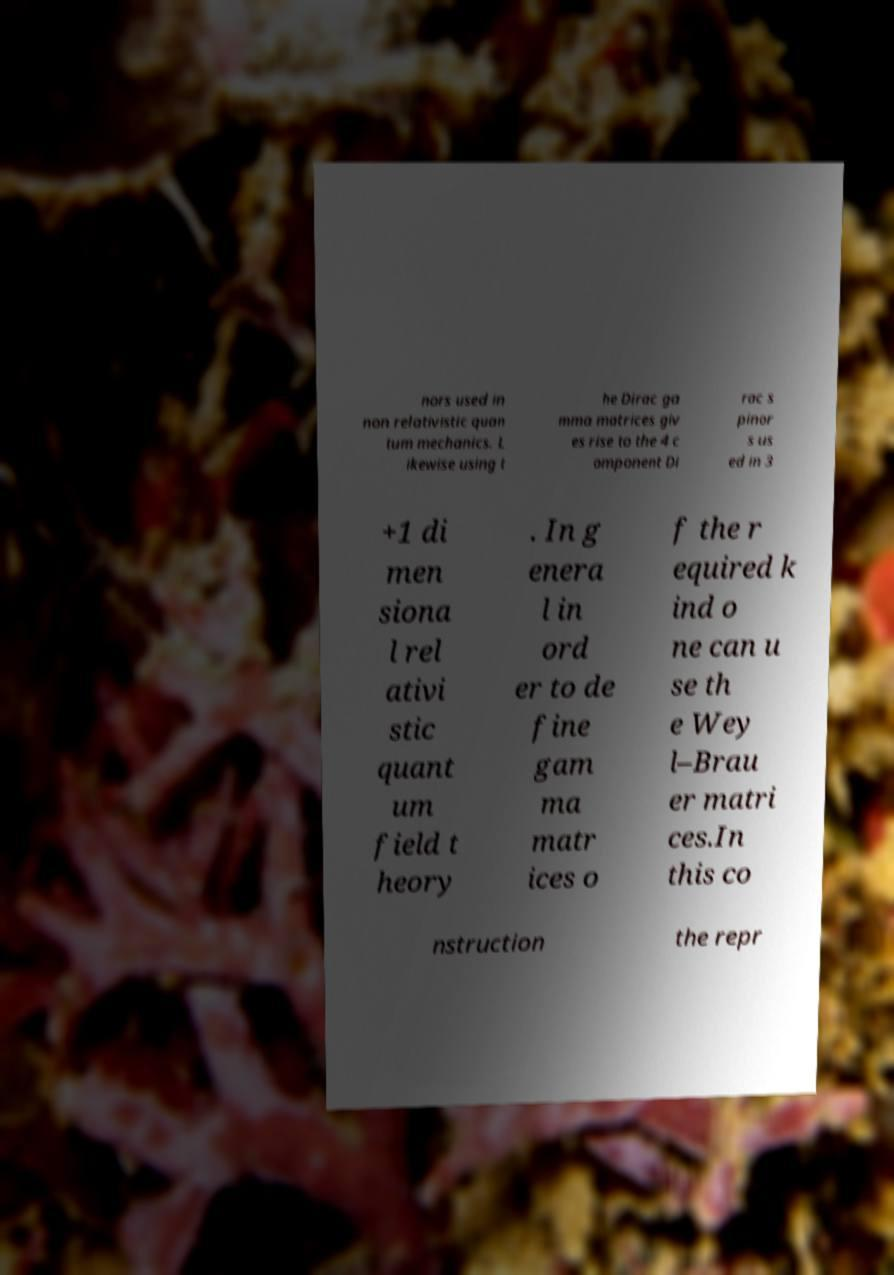Please identify and transcribe the text found in this image. nors used in non relativistic quan tum mechanics. L ikewise using t he Dirac ga mma matrices giv es rise to the 4 c omponent Di rac s pinor s us ed in 3 +1 di men siona l rel ativi stic quant um field t heory . In g enera l in ord er to de fine gam ma matr ices o f the r equired k ind o ne can u se th e Wey l–Brau er matri ces.In this co nstruction the repr 